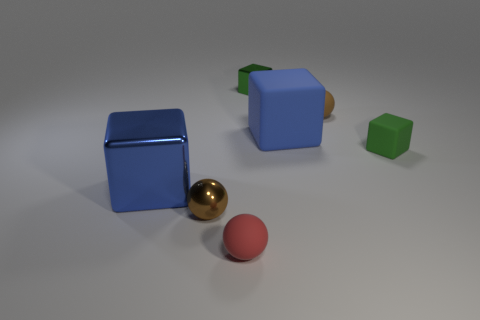Subtract all green matte cubes. How many cubes are left? 3 Add 2 green things. How many objects exist? 9 Subtract all green cubes. How many cubes are left? 2 Subtract all balls. How many objects are left? 4 Subtract 2 blocks. How many blocks are left? 2 Subtract all blue cylinders. How many blue blocks are left? 2 Add 1 big blue cubes. How many big blue cubes exist? 3 Subtract 1 brown balls. How many objects are left? 6 Subtract all cyan blocks. Subtract all cyan cylinders. How many blocks are left? 4 Subtract all tiny brown shiny things. Subtract all brown things. How many objects are left? 4 